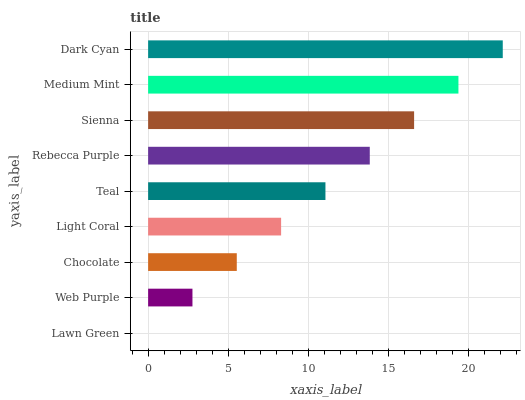Is Lawn Green the minimum?
Answer yes or no. Yes. Is Dark Cyan the maximum?
Answer yes or no. Yes. Is Web Purple the minimum?
Answer yes or no. No. Is Web Purple the maximum?
Answer yes or no. No. Is Web Purple greater than Lawn Green?
Answer yes or no. Yes. Is Lawn Green less than Web Purple?
Answer yes or no. Yes. Is Lawn Green greater than Web Purple?
Answer yes or no. No. Is Web Purple less than Lawn Green?
Answer yes or no. No. Is Teal the high median?
Answer yes or no. Yes. Is Teal the low median?
Answer yes or no. Yes. Is Dark Cyan the high median?
Answer yes or no. No. Is Light Coral the low median?
Answer yes or no. No. 